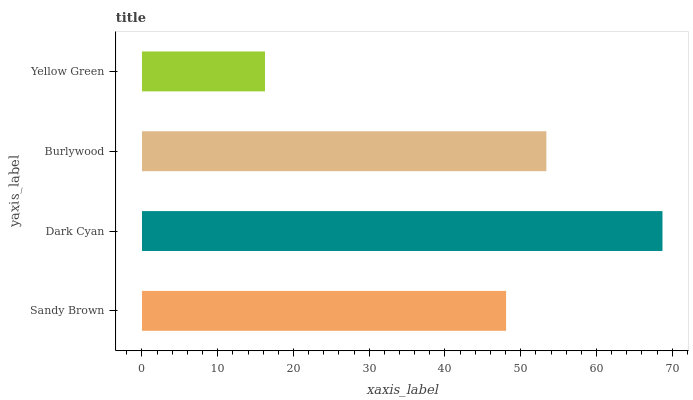Is Yellow Green the minimum?
Answer yes or no. Yes. Is Dark Cyan the maximum?
Answer yes or no. Yes. Is Burlywood the minimum?
Answer yes or no. No. Is Burlywood the maximum?
Answer yes or no. No. Is Dark Cyan greater than Burlywood?
Answer yes or no. Yes. Is Burlywood less than Dark Cyan?
Answer yes or no. Yes. Is Burlywood greater than Dark Cyan?
Answer yes or no. No. Is Dark Cyan less than Burlywood?
Answer yes or no. No. Is Burlywood the high median?
Answer yes or no. Yes. Is Sandy Brown the low median?
Answer yes or no. Yes. Is Dark Cyan the high median?
Answer yes or no. No. Is Dark Cyan the low median?
Answer yes or no. No. 